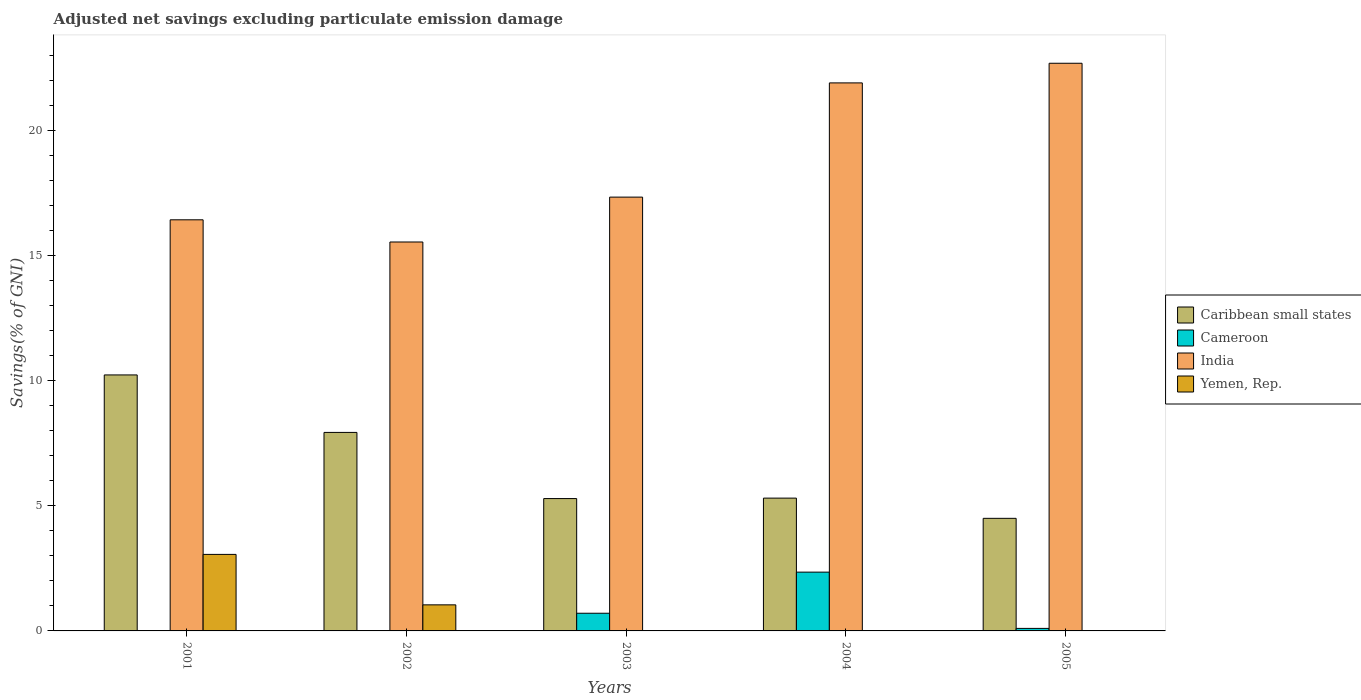Are the number of bars per tick equal to the number of legend labels?
Your response must be concise. No. How many bars are there on the 5th tick from the right?
Keep it short and to the point. 3. What is the label of the 2nd group of bars from the left?
Provide a succinct answer. 2002. In how many cases, is the number of bars for a given year not equal to the number of legend labels?
Provide a succinct answer. 5. What is the adjusted net savings in India in 2005?
Your answer should be very brief. 22.68. Across all years, what is the maximum adjusted net savings in Yemen, Rep.?
Your response must be concise. 3.06. Across all years, what is the minimum adjusted net savings in Caribbean small states?
Ensure brevity in your answer.  4.5. In which year was the adjusted net savings in Yemen, Rep. maximum?
Offer a terse response. 2001. What is the total adjusted net savings in Caribbean small states in the graph?
Your answer should be compact. 33.25. What is the difference between the adjusted net savings in India in 2002 and that in 2004?
Make the answer very short. -6.36. What is the difference between the adjusted net savings in Cameroon in 2003 and the adjusted net savings in India in 2004?
Make the answer very short. -21.19. What is the average adjusted net savings in Caribbean small states per year?
Provide a succinct answer. 6.65. In the year 2005, what is the difference between the adjusted net savings in Caribbean small states and adjusted net savings in India?
Ensure brevity in your answer.  -18.18. What is the ratio of the adjusted net savings in India in 2002 to that in 2004?
Your answer should be very brief. 0.71. What is the difference between the highest and the second highest adjusted net savings in Caribbean small states?
Provide a succinct answer. 2.3. What is the difference between the highest and the lowest adjusted net savings in Caribbean small states?
Your answer should be very brief. 5.73. In how many years, is the adjusted net savings in Caribbean small states greater than the average adjusted net savings in Caribbean small states taken over all years?
Offer a very short reply. 2. Is it the case that in every year, the sum of the adjusted net savings in India and adjusted net savings in Caribbean small states is greater than the adjusted net savings in Yemen, Rep.?
Your answer should be compact. Yes. How many bars are there?
Offer a very short reply. 15. How many years are there in the graph?
Make the answer very short. 5. Where does the legend appear in the graph?
Provide a short and direct response. Center right. How many legend labels are there?
Make the answer very short. 4. What is the title of the graph?
Ensure brevity in your answer.  Adjusted net savings excluding particulate emission damage. What is the label or title of the Y-axis?
Make the answer very short. Savings(% of GNI). What is the Savings(% of GNI) in Caribbean small states in 2001?
Make the answer very short. 10.23. What is the Savings(% of GNI) in India in 2001?
Offer a terse response. 16.42. What is the Savings(% of GNI) of Yemen, Rep. in 2001?
Offer a very short reply. 3.06. What is the Savings(% of GNI) in Caribbean small states in 2002?
Your response must be concise. 7.93. What is the Savings(% of GNI) of India in 2002?
Keep it short and to the point. 15.54. What is the Savings(% of GNI) of Yemen, Rep. in 2002?
Give a very brief answer. 1.04. What is the Savings(% of GNI) in Caribbean small states in 2003?
Provide a succinct answer. 5.29. What is the Savings(% of GNI) of Cameroon in 2003?
Keep it short and to the point. 0.71. What is the Savings(% of GNI) in India in 2003?
Your response must be concise. 17.33. What is the Savings(% of GNI) in Caribbean small states in 2004?
Your answer should be compact. 5.31. What is the Savings(% of GNI) of Cameroon in 2004?
Make the answer very short. 2.35. What is the Savings(% of GNI) in India in 2004?
Your answer should be very brief. 21.89. What is the Savings(% of GNI) of Yemen, Rep. in 2004?
Give a very brief answer. 0. What is the Savings(% of GNI) of Caribbean small states in 2005?
Offer a very short reply. 4.5. What is the Savings(% of GNI) of Cameroon in 2005?
Give a very brief answer. 0.1. What is the Savings(% of GNI) in India in 2005?
Provide a short and direct response. 22.68. Across all years, what is the maximum Savings(% of GNI) of Caribbean small states?
Offer a very short reply. 10.23. Across all years, what is the maximum Savings(% of GNI) of Cameroon?
Your answer should be compact. 2.35. Across all years, what is the maximum Savings(% of GNI) in India?
Offer a terse response. 22.68. Across all years, what is the maximum Savings(% of GNI) in Yemen, Rep.?
Offer a very short reply. 3.06. Across all years, what is the minimum Savings(% of GNI) in Caribbean small states?
Your answer should be compact. 4.5. Across all years, what is the minimum Savings(% of GNI) in Cameroon?
Make the answer very short. 0. Across all years, what is the minimum Savings(% of GNI) in India?
Ensure brevity in your answer.  15.54. What is the total Savings(% of GNI) in Caribbean small states in the graph?
Your answer should be very brief. 33.25. What is the total Savings(% of GNI) of Cameroon in the graph?
Ensure brevity in your answer.  3.16. What is the total Savings(% of GNI) of India in the graph?
Ensure brevity in your answer.  93.86. What is the total Savings(% of GNI) in Yemen, Rep. in the graph?
Offer a terse response. 4.1. What is the difference between the Savings(% of GNI) of Caribbean small states in 2001 and that in 2002?
Your response must be concise. 2.3. What is the difference between the Savings(% of GNI) in India in 2001 and that in 2002?
Make the answer very short. 0.89. What is the difference between the Savings(% of GNI) of Yemen, Rep. in 2001 and that in 2002?
Offer a very short reply. 2.02. What is the difference between the Savings(% of GNI) of Caribbean small states in 2001 and that in 2003?
Provide a succinct answer. 4.94. What is the difference between the Savings(% of GNI) of India in 2001 and that in 2003?
Keep it short and to the point. -0.91. What is the difference between the Savings(% of GNI) of Caribbean small states in 2001 and that in 2004?
Give a very brief answer. 4.92. What is the difference between the Savings(% of GNI) of India in 2001 and that in 2004?
Your answer should be very brief. -5.47. What is the difference between the Savings(% of GNI) in Caribbean small states in 2001 and that in 2005?
Your response must be concise. 5.73. What is the difference between the Savings(% of GNI) of India in 2001 and that in 2005?
Ensure brevity in your answer.  -6.25. What is the difference between the Savings(% of GNI) of Caribbean small states in 2002 and that in 2003?
Offer a terse response. 2.64. What is the difference between the Savings(% of GNI) in India in 2002 and that in 2003?
Offer a very short reply. -1.79. What is the difference between the Savings(% of GNI) in Caribbean small states in 2002 and that in 2004?
Your answer should be very brief. 2.62. What is the difference between the Savings(% of GNI) of India in 2002 and that in 2004?
Make the answer very short. -6.36. What is the difference between the Savings(% of GNI) in Caribbean small states in 2002 and that in 2005?
Make the answer very short. 3.43. What is the difference between the Savings(% of GNI) of India in 2002 and that in 2005?
Give a very brief answer. -7.14. What is the difference between the Savings(% of GNI) in Caribbean small states in 2003 and that in 2004?
Give a very brief answer. -0.02. What is the difference between the Savings(% of GNI) in Cameroon in 2003 and that in 2004?
Your response must be concise. -1.64. What is the difference between the Savings(% of GNI) in India in 2003 and that in 2004?
Your answer should be very brief. -4.56. What is the difference between the Savings(% of GNI) of Caribbean small states in 2003 and that in 2005?
Make the answer very short. 0.79. What is the difference between the Savings(% of GNI) of Cameroon in 2003 and that in 2005?
Your answer should be compact. 0.61. What is the difference between the Savings(% of GNI) of India in 2003 and that in 2005?
Give a very brief answer. -5.35. What is the difference between the Savings(% of GNI) of Caribbean small states in 2004 and that in 2005?
Your response must be concise. 0.81. What is the difference between the Savings(% of GNI) of Cameroon in 2004 and that in 2005?
Ensure brevity in your answer.  2.25. What is the difference between the Savings(% of GNI) in India in 2004 and that in 2005?
Offer a very short reply. -0.78. What is the difference between the Savings(% of GNI) of Caribbean small states in 2001 and the Savings(% of GNI) of India in 2002?
Make the answer very short. -5.31. What is the difference between the Savings(% of GNI) of Caribbean small states in 2001 and the Savings(% of GNI) of Yemen, Rep. in 2002?
Offer a very short reply. 9.18. What is the difference between the Savings(% of GNI) in India in 2001 and the Savings(% of GNI) in Yemen, Rep. in 2002?
Make the answer very short. 15.38. What is the difference between the Savings(% of GNI) in Caribbean small states in 2001 and the Savings(% of GNI) in Cameroon in 2003?
Provide a short and direct response. 9.52. What is the difference between the Savings(% of GNI) in Caribbean small states in 2001 and the Savings(% of GNI) in India in 2003?
Your answer should be compact. -7.1. What is the difference between the Savings(% of GNI) of Caribbean small states in 2001 and the Savings(% of GNI) of Cameroon in 2004?
Provide a short and direct response. 7.88. What is the difference between the Savings(% of GNI) in Caribbean small states in 2001 and the Savings(% of GNI) in India in 2004?
Offer a terse response. -11.67. What is the difference between the Savings(% of GNI) of Caribbean small states in 2001 and the Savings(% of GNI) of Cameroon in 2005?
Offer a very short reply. 10.13. What is the difference between the Savings(% of GNI) of Caribbean small states in 2001 and the Savings(% of GNI) of India in 2005?
Your answer should be compact. -12.45. What is the difference between the Savings(% of GNI) in Caribbean small states in 2002 and the Savings(% of GNI) in Cameroon in 2003?
Provide a short and direct response. 7.22. What is the difference between the Savings(% of GNI) in Caribbean small states in 2002 and the Savings(% of GNI) in India in 2003?
Your answer should be very brief. -9.4. What is the difference between the Savings(% of GNI) of Caribbean small states in 2002 and the Savings(% of GNI) of Cameroon in 2004?
Your answer should be compact. 5.58. What is the difference between the Savings(% of GNI) of Caribbean small states in 2002 and the Savings(% of GNI) of India in 2004?
Give a very brief answer. -13.96. What is the difference between the Savings(% of GNI) of Caribbean small states in 2002 and the Savings(% of GNI) of Cameroon in 2005?
Your response must be concise. 7.83. What is the difference between the Savings(% of GNI) of Caribbean small states in 2002 and the Savings(% of GNI) of India in 2005?
Provide a succinct answer. -14.75. What is the difference between the Savings(% of GNI) of Caribbean small states in 2003 and the Savings(% of GNI) of Cameroon in 2004?
Your answer should be very brief. 2.94. What is the difference between the Savings(% of GNI) in Caribbean small states in 2003 and the Savings(% of GNI) in India in 2004?
Make the answer very short. -16.61. What is the difference between the Savings(% of GNI) in Cameroon in 2003 and the Savings(% of GNI) in India in 2004?
Your answer should be compact. -21.19. What is the difference between the Savings(% of GNI) in Caribbean small states in 2003 and the Savings(% of GNI) in Cameroon in 2005?
Provide a short and direct response. 5.19. What is the difference between the Savings(% of GNI) in Caribbean small states in 2003 and the Savings(% of GNI) in India in 2005?
Offer a terse response. -17.39. What is the difference between the Savings(% of GNI) in Cameroon in 2003 and the Savings(% of GNI) in India in 2005?
Ensure brevity in your answer.  -21.97. What is the difference between the Savings(% of GNI) of Caribbean small states in 2004 and the Savings(% of GNI) of Cameroon in 2005?
Offer a very short reply. 5.2. What is the difference between the Savings(% of GNI) of Caribbean small states in 2004 and the Savings(% of GNI) of India in 2005?
Provide a short and direct response. -17.37. What is the difference between the Savings(% of GNI) in Cameroon in 2004 and the Savings(% of GNI) in India in 2005?
Your answer should be very brief. -20.33. What is the average Savings(% of GNI) of Caribbean small states per year?
Your answer should be compact. 6.65. What is the average Savings(% of GNI) in Cameroon per year?
Your answer should be very brief. 0.63. What is the average Savings(% of GNI) in India per year?
Ensure brevity in your answer.  18.77. What is the average Savings(% of GNI) in Yemen, Rep. per year?
Give a very brief answer. 0.82. In the year 2001, what is the difference between the Savings(% of GNI) of Caribbean small states and Savings(% of GNI) of India?
Provide a succinct answer. -6.2. In the year 2001, what is the difference between the Savings(% of GNI) of Caribbean small states and Savings(% of GNI) of Yemen, Rep.?
Provide a short and direct response. 7.17. In the year 2001, what is the difference between the Savings(% of GNI) of India and Savings(% of GNI) of Yemen, Rep.?
Offer a very short reply. 13.37. In the year 2002, what is the difference between the Savings(% of GNI) of Caribbean small states and Savings(% of GNI) of India?
Give a very brief answer. -7.61. In the year 2002, what is the difference between the Savings(% of GNI) in Caribbean small states and Savings(% of GNI) in Yemen, Rep.?
Provide a succinct answer. 6.89. In the year 2002, what is the difference between the Savings(% of GNI) in India and Savings(% of GNI) in Yemen, Rep.?
Give a very brief answer. 14.5. In the year 2003, what is the difference between the Savings(% of GNI) in Caribbean small states and Savings(% of GNI) in Cameroon?
Your response must be concise. 4.58. In the year 2003, what is the difference between the Savings(% of GNI) of Caribbean small states and Savings(% of GNI) of India?
Offer a terse response. -12.04. In the year 2003, what is the difference between the Savings(% of GNI) of Cameroon and Savings(% of GNI) of India?
Offer a terse response. -16.62. In the year 2004, what is the difference between the Savings(% of GNI) of Caribbean small states and Savings(% of GNI) of Cameroon?
Your answer should be very brief. 2.96. In the year 2004, what is the difference between the Savings(% of GNI) of Caribbean small states and Savings(% of GNI) of India?
Your answer should be very brief. -16.59. In the year 2004, what is the difference between the Savings(% of GNI) of Cameroon and Savings(% of GNI) of India?
Provide a succinct answer. -19.54. In the year 2005, what is the difference between the Savings(% of GNI) of Caribbean small states and Savings(% of GNI) of Cameroon?
Your answer should be very brief. 4.4. In the year 2005, what is the difference between the Savings(% of GNI) of Caribbean small states and Savings(% of GNI) of India?
Your answer should be very brief. -18.18. In the year 2005, what is the difference between the Savings(% of GNI) in Cameroon and Savings(% of GNI) in India?
Your answer should be very brief. -22.58. What is the ratio of the Savings(% of GNI) of Caribbean small states in 2001 to that in 2002?
Provide a succinct answer. 1.29. What is the ratio of the Savings(% of GNI) in India in 2001 to that in 2002?
Your answer should be very brief. 1.06. What is the ratio of the Savings(% of GNI) in Yemen, Rep. in 2001 to that in 2002?
Offer a terse response. 2.93. What is the ratio of the Savings(% of GNI) of Caribbean small states in 2001 to that in 2003?
Provide a succinct answer. 1.93. What is the ratio of the Savings(% of GNI) of India in 2001 to that in 2003?
Give a very brief answer. 0.95. What is the ratio of the Savings(% of GNI) of Caribbean small states in 2001 to that in 2004?
Your answer should be compact. 1.93. What is the ratio of the Savings(% of GNI) in India in 2001 to that in 2004?
Provide a short and direct response. 0.75. What is the ratio of the Savings(% of GNI) in Caribbean small states in 2001 to that in 2005?
Your answer should be compact. 2.27. What is the ratio of the Savings(% of GNI) of India in 2001 to that in 2005?
Make the answer very short. 0.72. What is the ratio of the Savings(% of GNI) of Caribbean small states in 2002 to that in 2003?
Offer a terse response. 1.5. What is the ratio of the Savings(% of GNI) in India in 2002 to that in 2003?
Offer a very short reply. 0.9. What is the ratio of the Savings(% of GNI) in Caribbean small states in 2002 to that in 2004?
Provide a succinct answer. 1.49. What is the ratio of the Savings(% of GNI) of India in 2002 to that in 2004?
Offer a very short reply. 0.71. What is the ratio of the Savings(% of GNI) of Caribbean small states in 2002 to that in 2005?
Provide a succinct answer. 1.76. What is the ratio of the Savings(% of GNI) in India in 2002 to that in 2005?
Make the answer very short. 0.69. What is the ratio of the Savings(% of GNI) of Cameroon in 2003 to that in 2004?
Your answer should be compact. 0.3. What is the ratio of the Savings(% of GNI) of India in 2003 to that in 2004?
Offer a very short reply. 0.79. What is the ratio of the Savings(% of GNI) of Caribbean small states in 2003 to that in 2005?
Offer a very short reply. 1.18. What is the ratio of the Savings(% of GNI) in Cameroon in 2003 to that in 2005?
Provide a short and direct response. 7. What is the ratio of the Savings(% of GNI) of India in 2003 to that in 2005?
Make the answer very short. 0.76. What is the ratio of the Savings(% of GNI) of Caribbean small states in 2004 to that in 2005?
Your answer should be very brief. 1.18. What is the ratio of the Savings(% of GNI) in Cameroon in 2004 to that in 2005?
Your answer should be compact. 23.28. What is the ratio of the Savings(% of GNI) of India in 2004 to that in 2005?
Ensure brevity in your answer.  0.97. What is the difference between the highest and the second highest Savings(% of GNI) of Caribbean small states?
Offer a very short reply. 2.3. What is the difference between the highest and the second highest Savings(% of GNI) in Cameroon?
Give a very brief answer. 1.64. What is the difference between the highest and the second highest Savings(% of GNI) of India?
Your answer should be very brief. 0.78. What is the difference between the highest and the lowest Savings(% of GNI) in Caribbean small states?
Your response must be concise. 5.73. What is the difference between the highest and the lowest Savings(% of GNI) of Cameroon?
Provide a succinct answer. 2.35. What is the difference between the highest and the lowest Savings(% of GNI) in India?
Give a very brief answer. 7.14. What is the difference between the highest and the lowest Savings(% of GNI) in Yemen, Rep.?
Offer a very short reply. 3.06. 